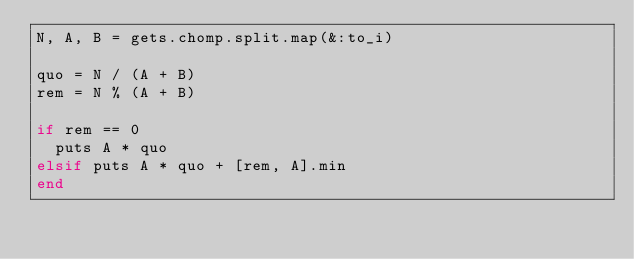<code> <loc_0><loc_0><loc_500><loc_500><_Ruby_>N, A, B = gets.chomp.split.map(&:to_i)

quo = N / (A + B)
rem = N % (A + B)

if rem == 0
  puts A * quo
elsif puts A * quo + [rem, A].min
end
</code> 